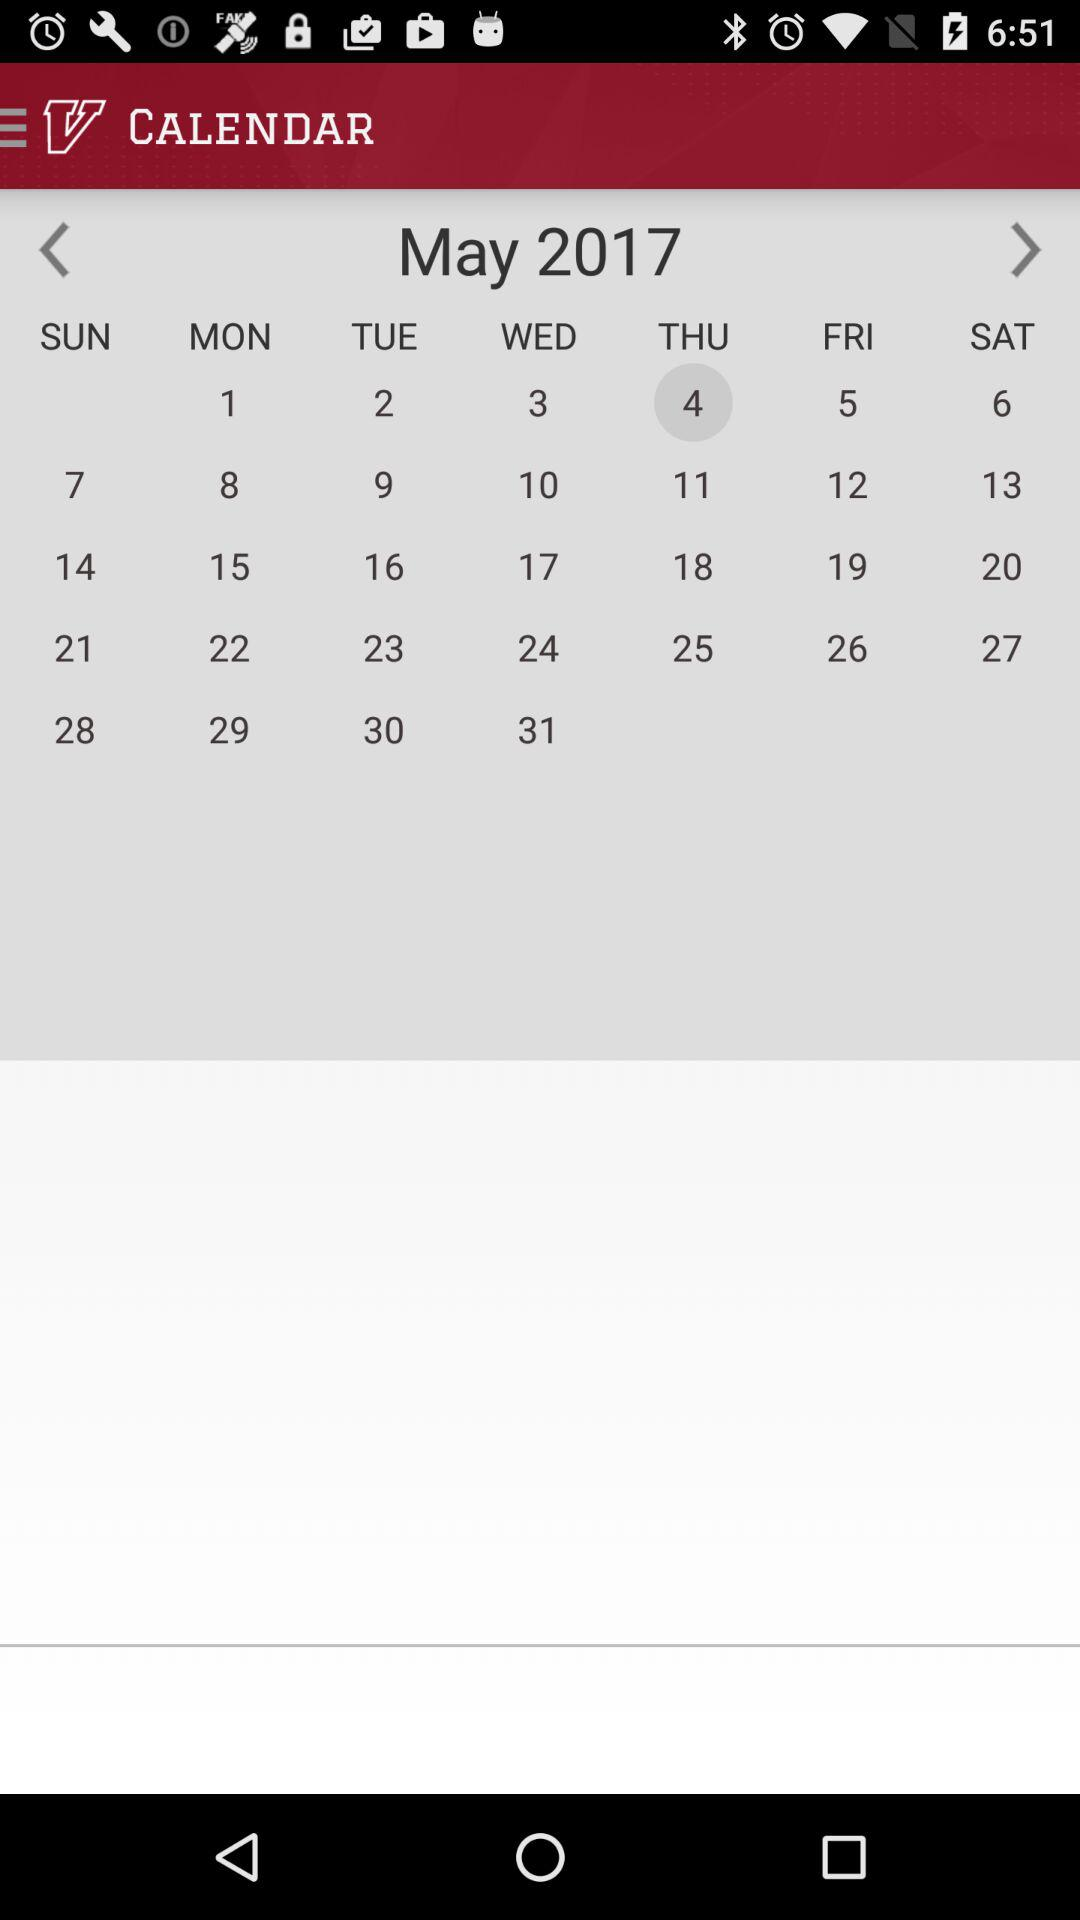Which is the selected date in the calendar? The selected date is May 4, 2017. 